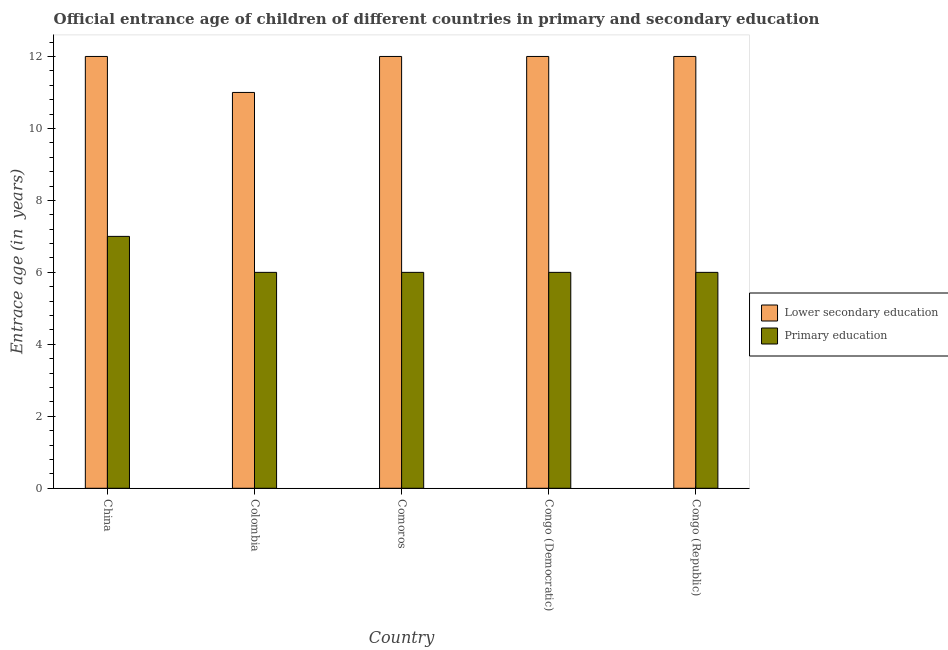How many different coloured bars are there?
Offer a very short reply. 2. Are the number of bars per tick equal to the number of legend labels?
Offer a terse response. Yes. How many bars are there on the 5th tick from the left?
Offer a terse response. 2. How many bars are there on the 3rd tick from the right?
Ensure brevity in your answer.  2. What is the label of the 5th group of bars from the left?
Your answer should be very brief. Congo (Republic). In how many cases, is the number of bars for a given country not equal to the number of legend labels?
Offer a very short reply. 0. What is the entrance age of children in lower secondary education in Congo (Democratic)?
Your response must be concise. 12. Across all countries, what is the maximum entrance age of chiildren in primary education?
Your answer should be very brief. 7. Across all countries, what is the minimum entrance age of children in lower secondary education?
Make the answer very short. 11. In which country was the entrance age of children in lower secondary education maximum?
Make the answer very short. China. What is the total entrance age of chiildren in primary education in the graph?
Make the answer very short. 31. What is the difference between the entrance age of children in lower secondary education in Colombia and the entrance age of chiildren in primary education in Congo (Democratic)?
Offer a terse response. 5. What is the difference between the entrance age of chiildren in primary education and entrance age of children in lower secondary education in Congo (Democratic)?
Provide a succinct answer. -6. In how many countries, is the entrance age of chiildren in primary education greater than 3.6 years?
Make the answer very short. 5. What is the ratio of the entrance age of children in lower secondary education in Colombia to that in Congo (Democratic)?
Keep it short and to the point. 0.92. What is the difference between the highest and the second highest entrance age of chiildren in primary education?
Your response must be concise. 1. What is the difference between the highest and the lowest entrance age of chiildren in primary education?
Ensure brevity in your answer.  1. In how many countries, is the entrance age of children in lower secondary education greater than the average entrance age of children in lower secondary education taken over all countries?
Offer a terse response. 4. What does the 2nd bar from the left in Congo (Republic) represents?
Provide a succinct answer. Primary education. What does the 2nd bar from the right in Congo (Republic) represents?
Offer a terse response. Lower secondary education. How many countries are there in the graph?
Your response must be concise. 5. Are the values on the major ticks of Y-axis written in scientific E-notation?
Offer a very short reply. No. Does the graph contain grids?
Provide a succinct answer. No. Where does the legend appear in the graph?
Offer a very short reply. Center right. What is the title of the graph?
Provide a succinct answer. Official entrance age of children of different countries in primary and secondary education. Does "Young" appear as one of the legend labels in the graph?
Ensure brevity in your answer.  No. What is the label or title of the Y-axis?
Ensure brevity in your answer.  Entrace age (in  years). What is the Entrace age (in  years) of Primary education in China?
Your answer should be compact. 7. What is the Entrace age (in  years) of Lower secondary education in Colombia?
Your response must be concise. 11. What is the Entrace age (in  years) in Primary education in Colombia?
Ensure brevity in your answer.  6. What is the Entrace age (in  years) of Primary education in Congo (Democratic)?
Offer a very short reply. 6. What is the Entrace age (in  years) of Lower secondary education in Congo (Republic)?
Offer a terse response. 12. What is the Entrace age (in  years) in Primary education in Congo (Republic)?
Your answer should be very brief. 6. Across all countries, what is the maximum Entrace age (in  years) in Lower secondary education?
Your answer should be compact. 12. Across all countries, what is the minimum Entrace age (in  years) of Primary education?
Your response must be concise. 6. What is the total Entrace age (in  years) of Lower secondary education in the graph?
Offer a terse response. 59. What is the total Entrace age (in  years) of Primary education in the graph?
Offer a very short reply. 31. What is the difference between the Entrace age (in  years) of Lower secondary education in China and that in Colombia?
Your answer should be compact. 1. What is the difference between the Entrace age (in  years) in Primary education in China and that in Colombia?
Ensure brevity in your answer.  1. What is the difference between the Entrace age (in  years) in Primary education in China and that in Congo (Democratic)?
Your answer should be very brief. 1. What is the difference between the Entrace age (in  years) of Lower secondary education in China and that in Congo (Republic)?
Make the answer very short. 0. What is the difference between the Entrace age (in  years) of Lower secondary education in Colombia and that in Comoros?
Give a very brief answer. -1. What is the difference between the Entrace age (in  years) in Lower secondary education in Colombia and that in Congo (Republic)?
Provide a short and direct response. -1. What is the difference between the Entrace age (in  years) in Lower secondary education in Comoros and that in Congo (Republic)?
Your answer should be very brief. 0. What is the difference between the Entrace age (in  years) in Primary education in Congo (Democratic) and that in Congo (Republic)?
Give a very brief answer. 0. What is the difference between the Entrace age (in  years) in Lower secondary education in China and the Entrace age (in  years) in Primary education in Congo (Democratic)?
Offer a very short reply. 6. What is the difference between the Entrace age (in  years) in Lower secondary education in China and the Entrace age (in  years) in Primary education in Congo (Republic)?
Ensure brevity in your answer.  6. What is the difference between the Entrace age (in  years) of Lower secondary education in Comoros and the Entrace age (in  years) of Primary education in Congo (Democratic)?
Make the answer very short. 6. What is the difference between the Entrace age (in  years) of Lower secondary education in Congo (Democratic) and the Entrace age (in  years) of Primary education in Congo (Republic)?
Provide a short and direct response. 6. What is the average Entrace age (in  years) in Lower secondary education per country?
Offer a terse response. 11.8. What is the difference between the Entrace age (in  years) in Lower secondary education and Entrace age (in  years) in Primary education in Colombia?
Your answer should be very brief. 5. What is the difference between the Entrace age (in  years) in Lower secondary education and Entrace age (in  years) in Primary education in Comoros?
Your answer should be compact. 6. What is the difference between the Entrace age (in  years) of Lower secondary education and Entrace age (in  years) of Primary education in Congo (Democratic)?
Your answer should be compact. 6. What is the ratio of the Entrace age (in  years) of Lower secondary education in China to that in Congo (Democratic)?
Provide a succinct answer. 1. What is the ratio of the Entrace age (in  years) of Primary education in China to that in Congo (Democratic)?
Offer a terse response. 1.17. What is the ratio of the Entrace age (in  years) of Lower secondary education in China to that in Congo (Republic)?
Your answer should be compact. 1. What is the ratio of the Entrace age (in  years) of Primary education in Colombia to that in Comoros?
Give a very brief answer. 1. What is the ratio of the Entrace age (in  years) in Lower secondary education in Colombia to that in Congo (Democratic)?
Make the answer very short. 0.92. What is the ratio of the Entrace age (in  years) of Primary education in Colombia to that in Congo (Democratic)?
Your answer should be very brief. 1. What is the ratio of the Entrace age (in  years) of Primary education in Colombia to that in Congo (Republic)?
Offer a terse response. 1. What is the ratio of the Entrace age (in  years) in Lower secondary education in Comoros to that in Congo (Republic)?
Make the answer very short. 1. What is the ratio of the Entrace age (in  years) in Primary education in Comoros to that in Congo (Republic)?
Your answer should be compact. 1. What is the ratio of the Entrace age (in  years) in Primary education in Congo (Democratic) to that in Congo (Republic)?
Provide a succinct answer. 1. What is the difference between the highest and the second highest Entrace age (in  years) in Primary education?
Give a very brief answer. 1. What is the difference between the highest and the lowest Entrace age (in  years) of Lower secondary education?
Keep it short and to the point. 1. 